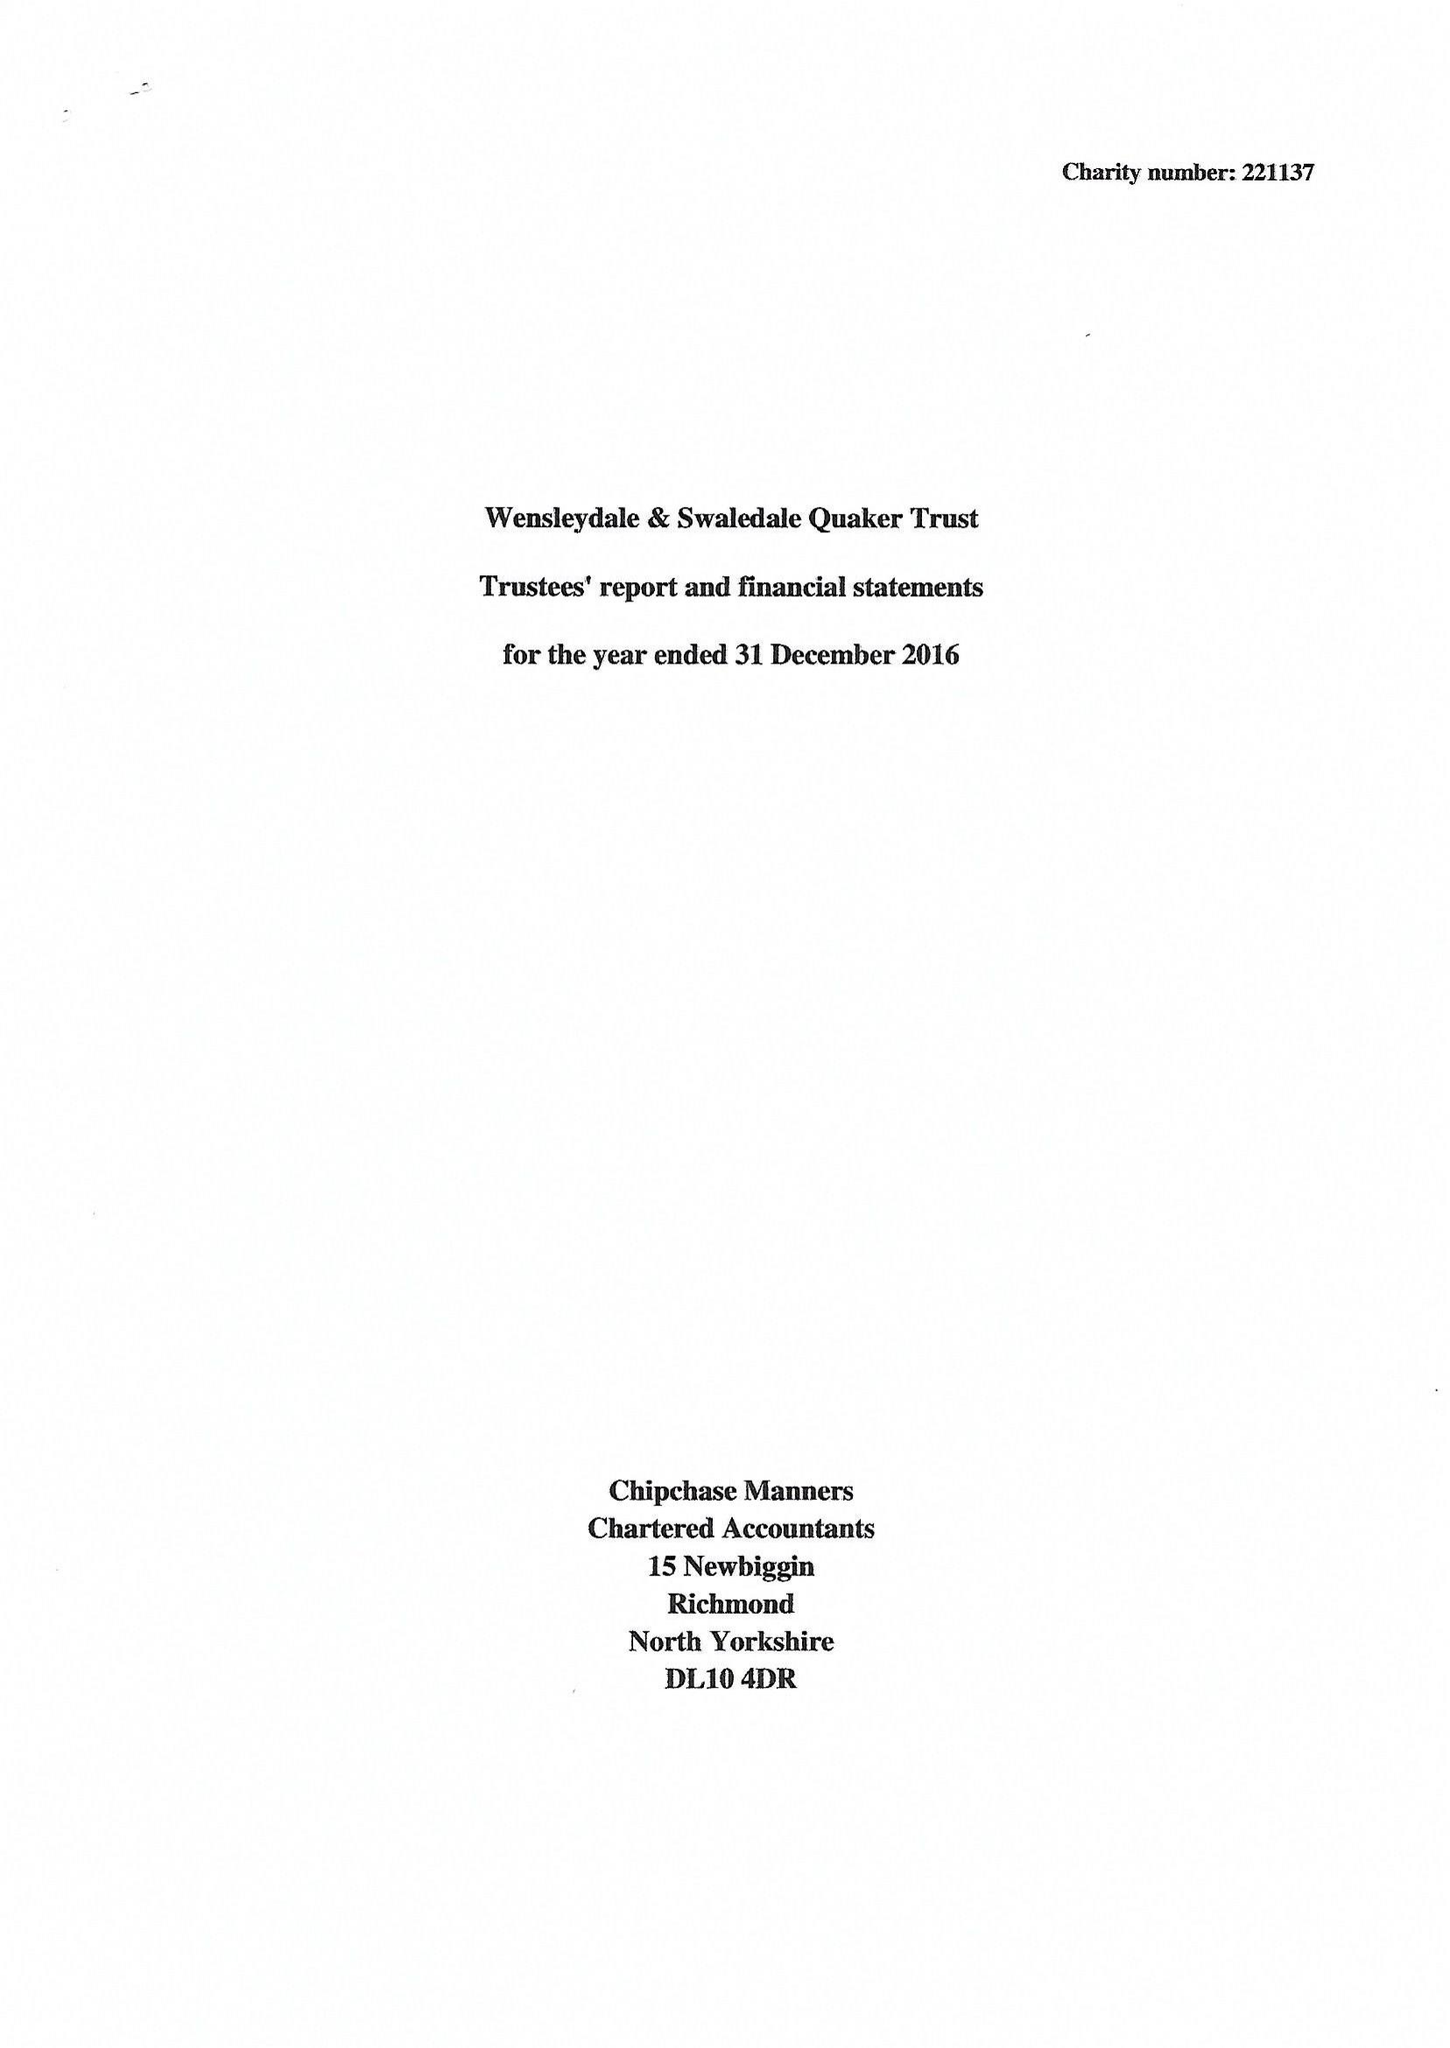What is the value for the address__postcode?
Answer the question using a single word or phrase. DL8 5AE 